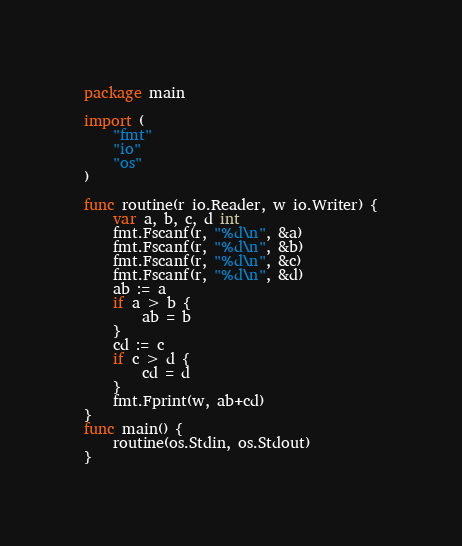Convert code to text. <code><loc_0><loc_0><loc_500><loc_500><_Go_>package main

import (
	"fmt"
	"io"
	"os"
)

func routine(r io.Reader, w io.Writer) {
	var a, b, c, d int
	fmt.Fscanf(r, "%d\n", &a)
	fmt.Fscanf(r, "%d\n", &b)
	fmt.Fscanf(r, "%d\n", &c)
	fmt.Fscanf(r, "%d\n", &d)
	ab := a
	if a > b {
		ab = b
	}
	cd := c
	if c > d {
		cd = d
	}
	fmt.Fprint(w, ab+cd)
}
func main() {
	routine(os.Stdin, os.Stdout)
}
</code> 